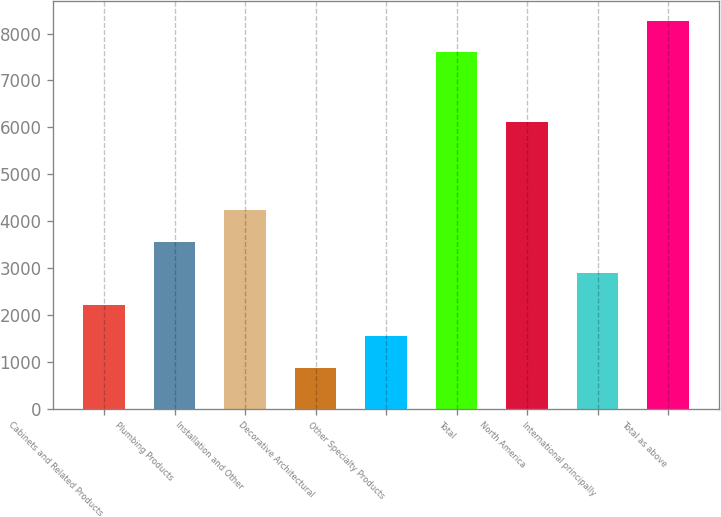Convert chart to OTSL. <chart><loc_0><loc_0><loc_500><loc_500><bar_chart><fcel>Cabinets and Related Products<fcel>Plumbing Products<fcel>Installation and Other<fcel>Decorative Architectural<fcel>Other Specialty Products<fcel>Total<fcel>North America<fcel>International principally<fcel>Total as above<nl><fcel>2217.6<fcel>3564.2<fcel>4237.5<fcel>871<fcel>1544.3<fcel>7604<fcel>6113<fcel>2890.9<fcel>8277.3<nl></chart> 